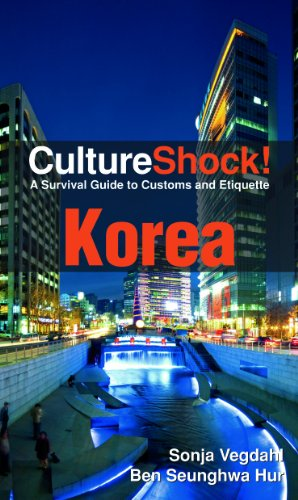What city is featured on the cover of this book? The city featured on the cover is Seoul, South Korea, recognizable by the modern architecture and bustling streets depicted in the nighttime image. 